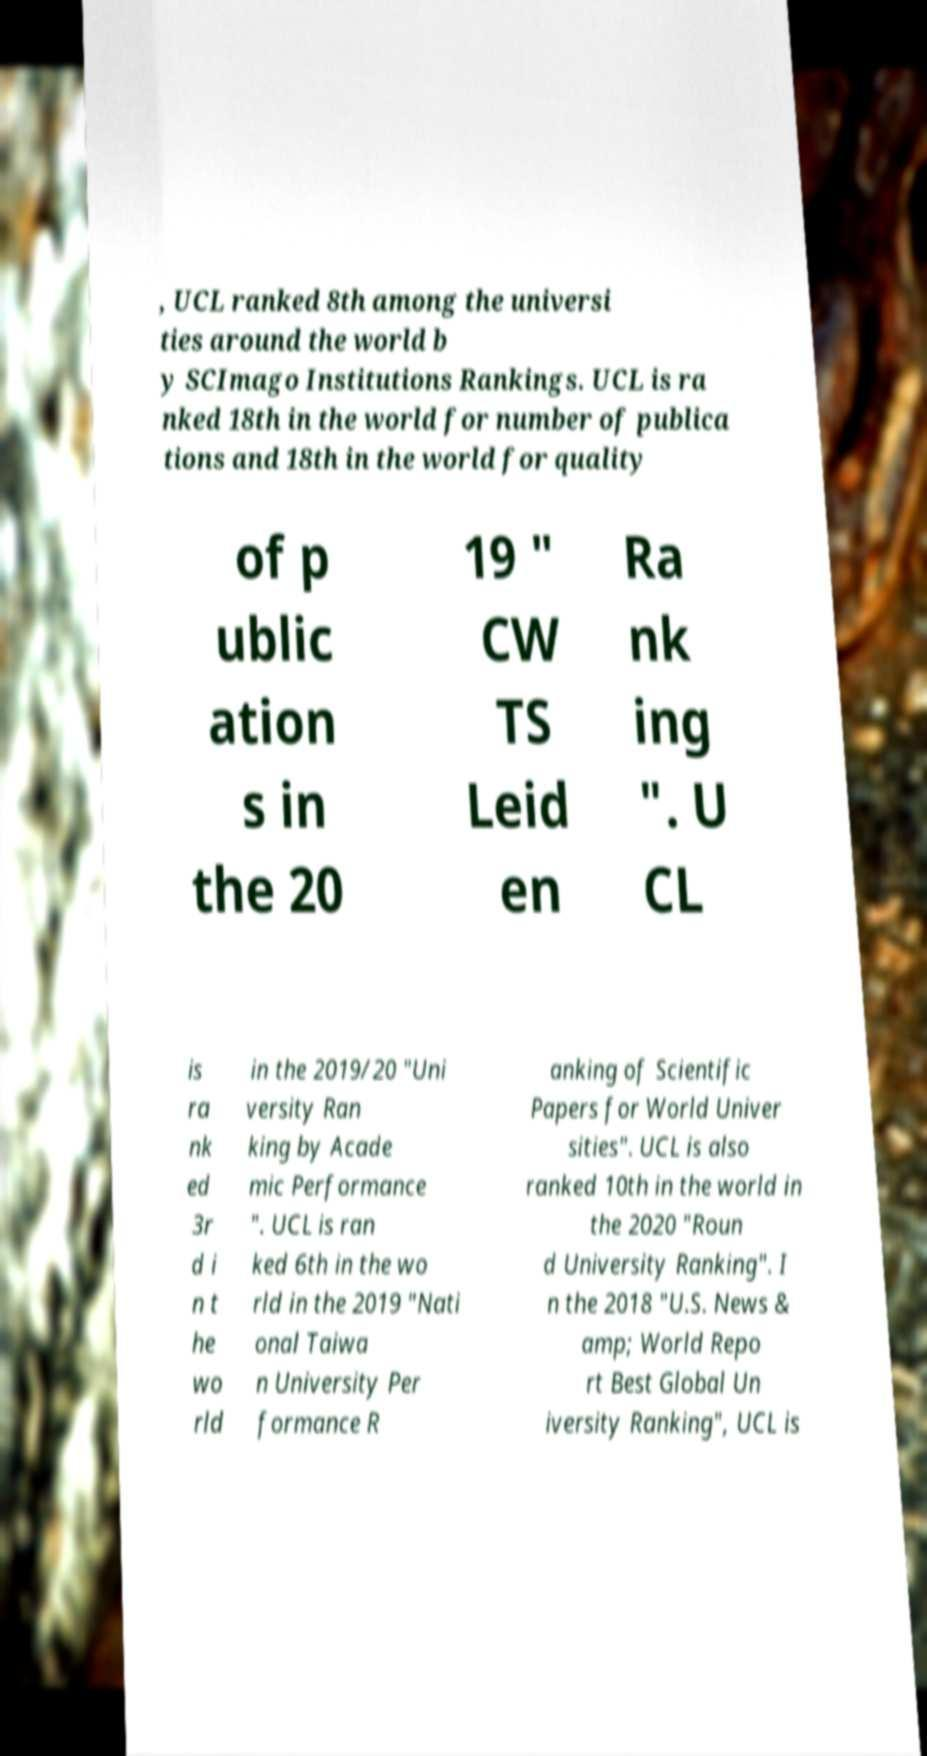Could you extract and type out the text from this image? , UCL ranked 8th among the universi ties around the world b y SCImago Institutions Rankings. UCL is ra nked 18th in the world for number of publica tions and 18th in the world for quality of p ublic ation s in the 20 19 " CW TS Leid en Ra nk ing ". U CL is ra nk ed 3r d i n t he wo rld in the 2019/20 "Uni versity Ran king by Acade mic Performance ". UCL is ran ked 6th in the wo rld in the 2019 "Nati onal Taiwa n University Per formance R anking of Scientific Papers for World Univer sities". UCL is also ranked 10th in the world in the 2020 "Roun d University Ranking". I n the 2018 "U.S. News & amp; World Repo rt Best Global Un iversity Ranking", UCL is 